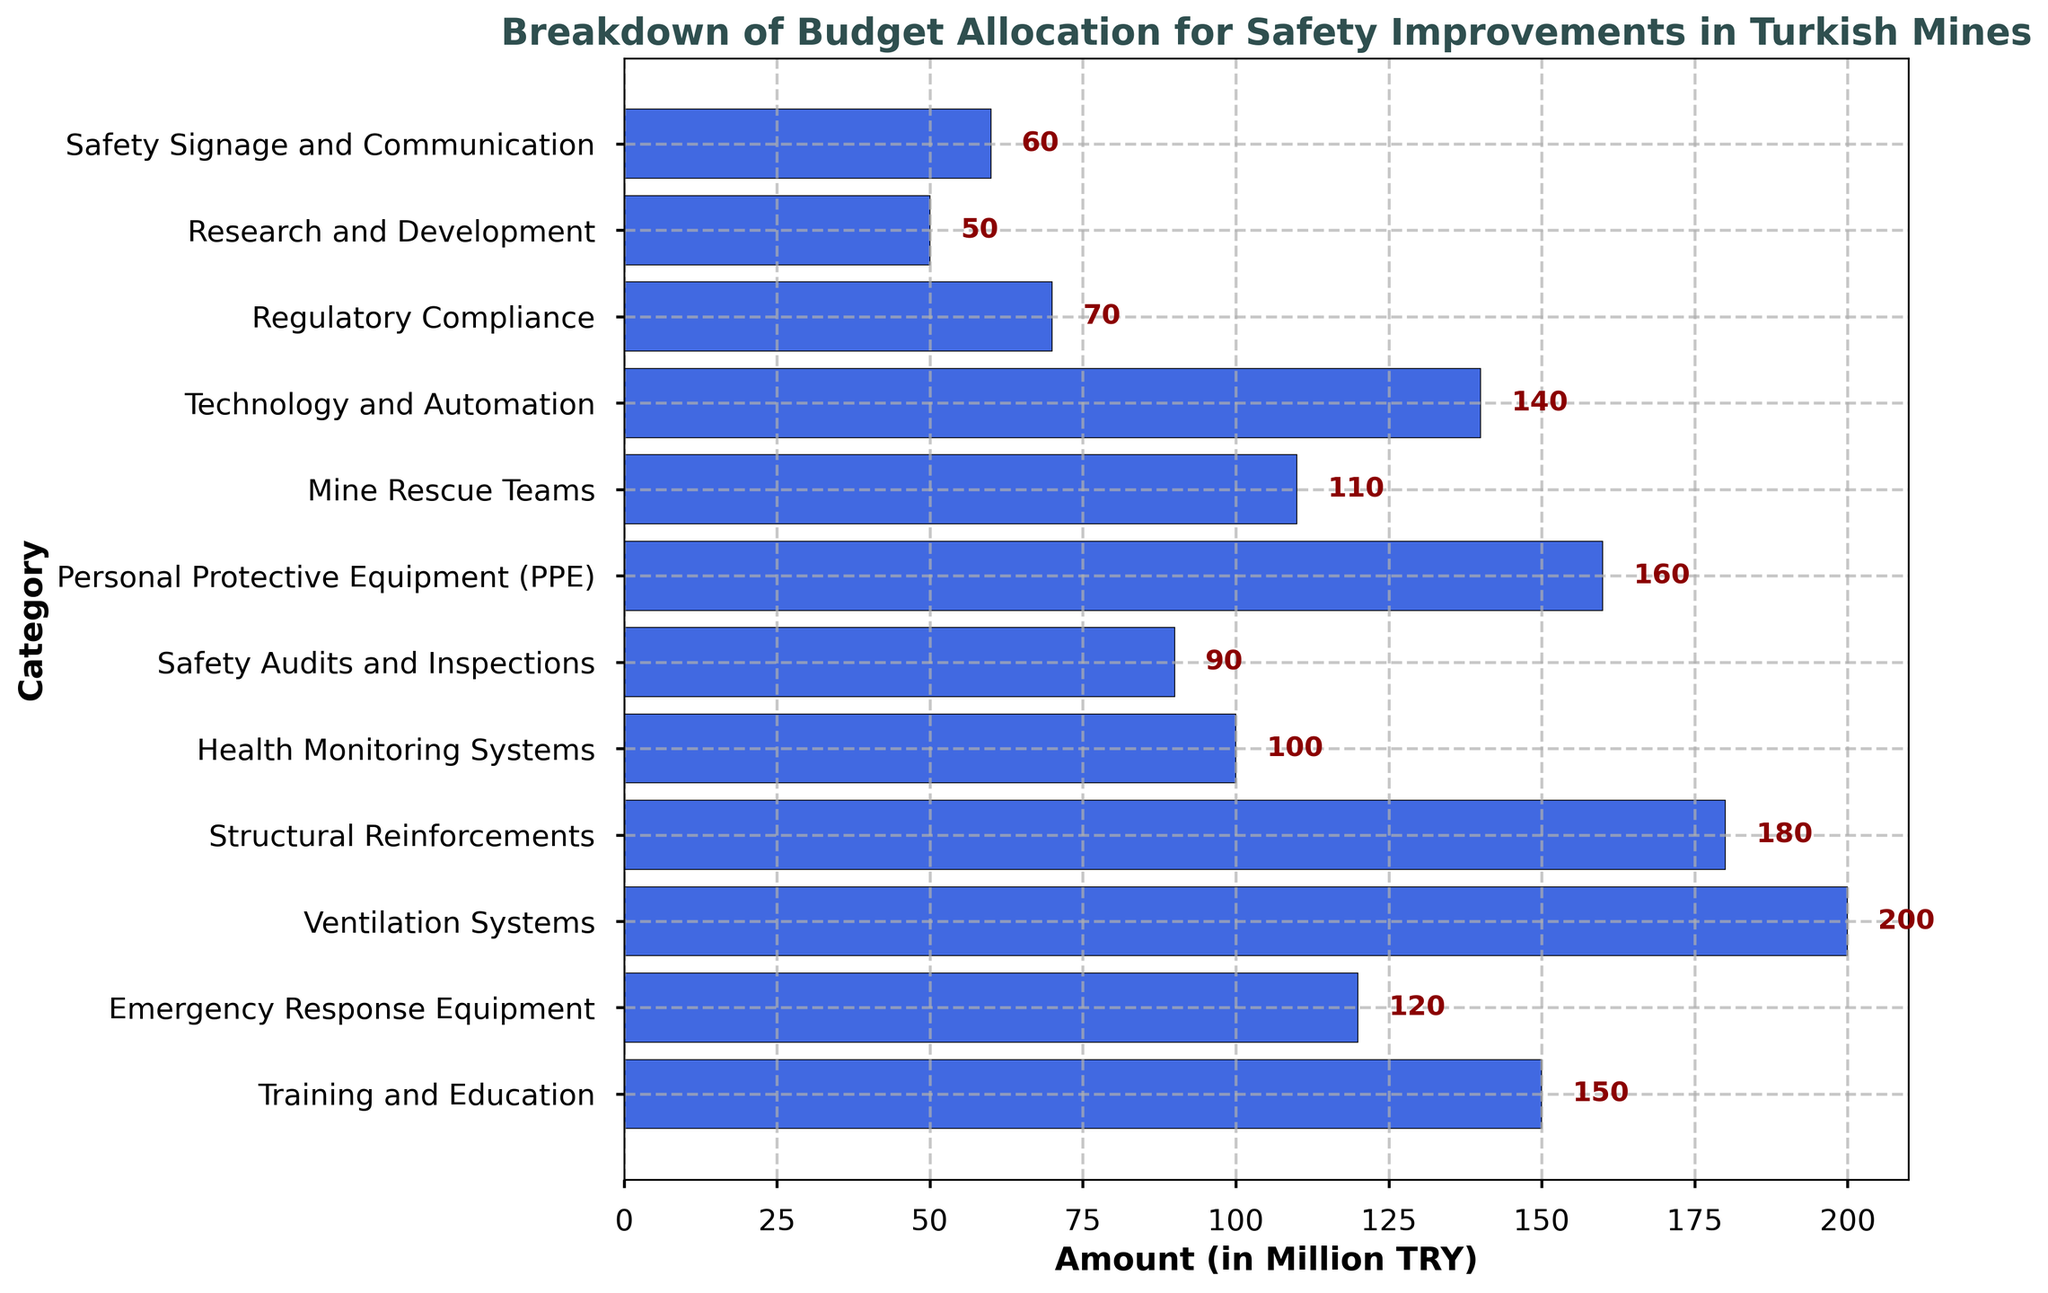Which category has the highest budget allocation? Visually, the longest bar represents the category with the highest budget allocation. By looking at the bar lengths, we can see that "Ventilation Systems" has the longest bar.
Answer: Ventilation Systems How much more is allocated for Training and Education compared to Health Monitoring Systems? To find the difference, subtract the total allocation for Health Monitoring Systems from Training and Education. Training and Education is 150 million TRY, and Health Monitoring Systems is 100 million TRY. So, 150 - 100 = 50
Answer: 50 million TRY What is the total budget for Personal Protective Equipment (PPE) and Technology and Automation combined? To calculate the total, add the amounts allocated to PPE and Technology and Automation. PPE is 160 million TRY, and Technology and Automation is 140 million TRY, so 160 + 140 = 300
Answer: 300 million TRY Is the amount allocated to Safety Audits and Inspections less than the amount for Mine Rescue Teams? Comparing the bar lengths, the length for Safety Audits and Inspections is shorter than that for Mine Rescue Teams. Safety Audits and Inspections have 90 million TRY, and Mine Rescue Teams have 110 million TRY.
Answer: Yes Which category has the smallest budget allocation? Visually, the shortest bar represents the category with the smallest budget allocation. By looking at the bar lengths, we can see that "Research and Development" has the shortest bar.
Answer: Research and Development What is the average budget for the categories Training and Education, Emergency Response Equipment, and Structural Reinforcements? First, find the sum of the budgets for these categories: Training and Education (150), Emergency Response Equipment (120), and Structural Reinforcements (180). The sum is 450. Then, divide this sum by the number of categories, which is 3. Therefore, the average budget is 450 / 3 = 150
Answer: 150 million TRY Calculate the total budget allocation for categories related to direct safety measures (i.e., categories that directly enhance safety on-site like PPE, Mine Rescue Teams). Sum the budgets for PPE (160), Mine Rescue Teams (110), Emergency Response Equipment (120), and Structural Reinforcements (180). Therefore, the total is 160 + 110 + 120 + 180 = 570
Answer: 570 million TRY Is the budget for Regulatory Compliance greater than Safety Signage and Communication? Comparing the bar lengths, Regulatory Compliance (70) is less than Safety Signage and Communication (60). Thus, Regulatory Compliance does not have a greater budget allocation.
Answer: No What is the difference in the budget allocation between the category with the highest allocation and the category with the lowest? First, identify the highest allocation which is Ventilation Systems (200) and the lowest which is Research and Development (50). The difference is 200 - 50 = 150.
Answer: 150 million TRY 